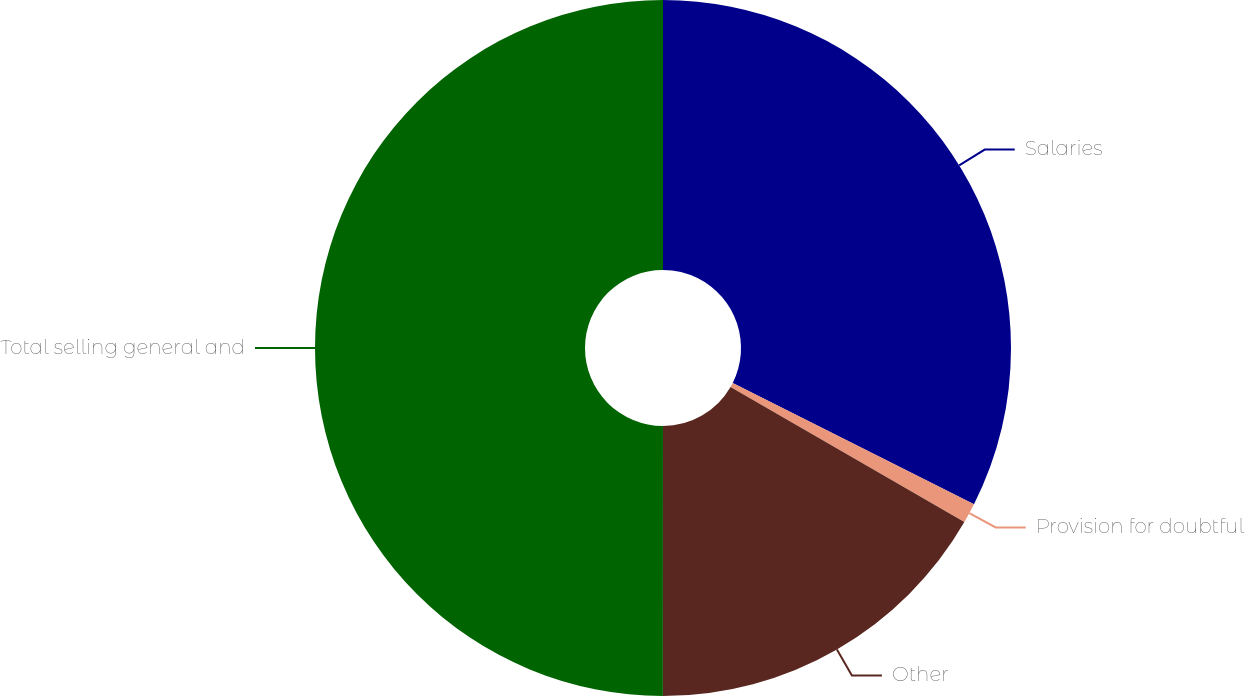Convert chart to OTSL. <chart><loc_0><loc_0><loc_500><loc_500><pie_chart><fcel>Salaries<fcel>Provision for doubtful<fcel>Other<fcel>Total selling general and<nl><fcel>32.41%<fcel>0.93%<fcel>16.67%<fcel>50.0%<nl></chart> 